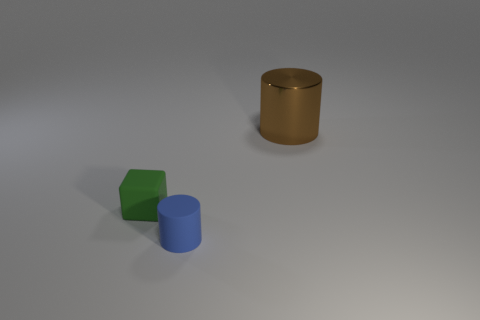How many big metallic cylinders are there?
Your response must be concise. 1. What number of objects are behind the tiny cylinder and in front of the large object?
Provide a succinct answer. 1. What is the material of the tiny blue object?
Give a very brief answer. Rubber. Are any rubber blocks visible?
Your answer should be compact. Yes. There is a matte thing that is right of the cube; what is its color?
Keep it short and to the point. Blue. What number of tiny matte objects are on the right side of the object behind the small matte thing that is on the left side of the tiny blue cylinder?
Your response must be concise. 0. There is a thing that is both to the right of the green matte object and behind the rubber cylinder; what material is it?
Your response must be concise. Metal. Is the material of the brown cylinder the same as the cylinder in front of the big brown object?
Provide a succinct answer. No. Are there more small green cubes on the left side of the metal cylinder than tiny green matte cubes in front of the tiny green matte thing?
Your response must be concise. Yes. The large brown metallic thing has what shape?
Your answer should be compact. Cylinder. 